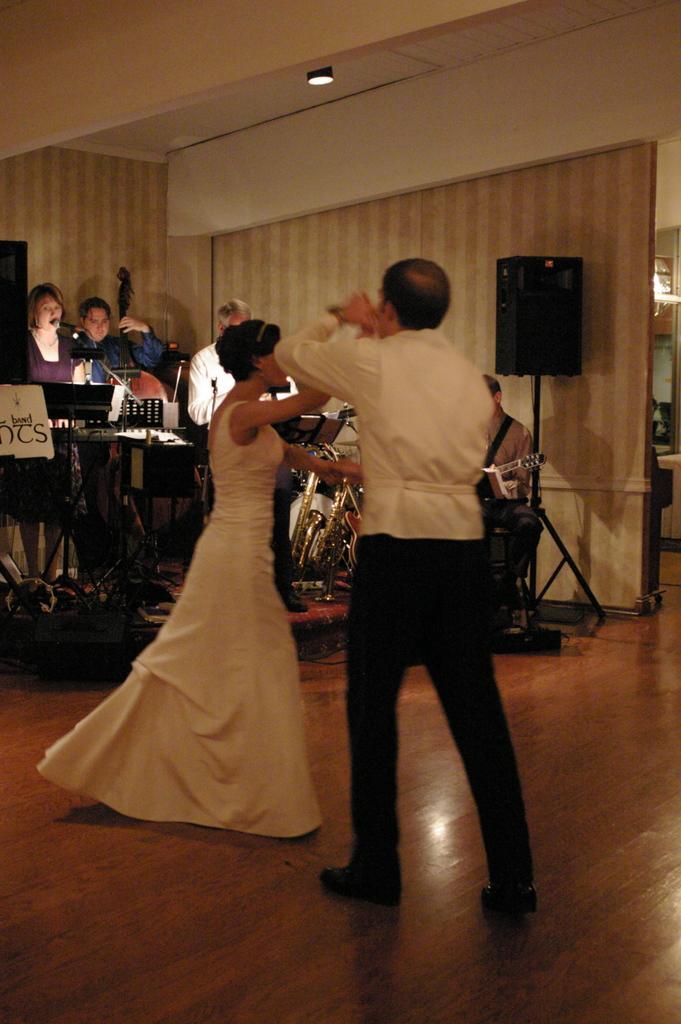Could you give a brief overview of what you see in this image? In this picture I can see two persons dancing , and in the background there are group of people, musical instruments, speakers with the stands. 